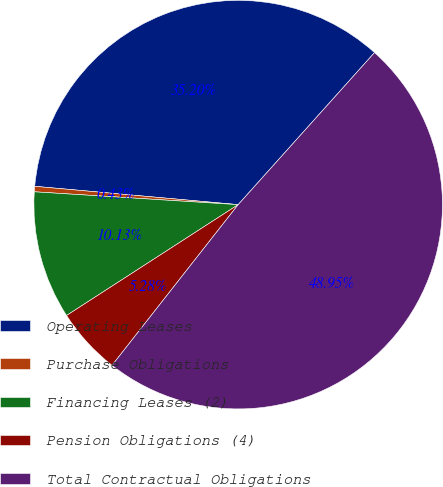Convert chart. <chart><loc_0><loc_0><loc_500><loc_500><pie_chart><fcel>Operating Leases<fcel>Purchase Obligations<fcel>Financing Leases (2)<fcel>Pension Obligations (4)<fcel>Total Contractual Obligations<nl><fcel>35.2%<fcel>0.43%<fcel>10.13%<fcel>5.28%<fcel>48.95%<nl></chart> 